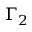<formula> <loc_0><loc_0><loc_500><loc_500>\Gamma _ { 2 }</formula> 